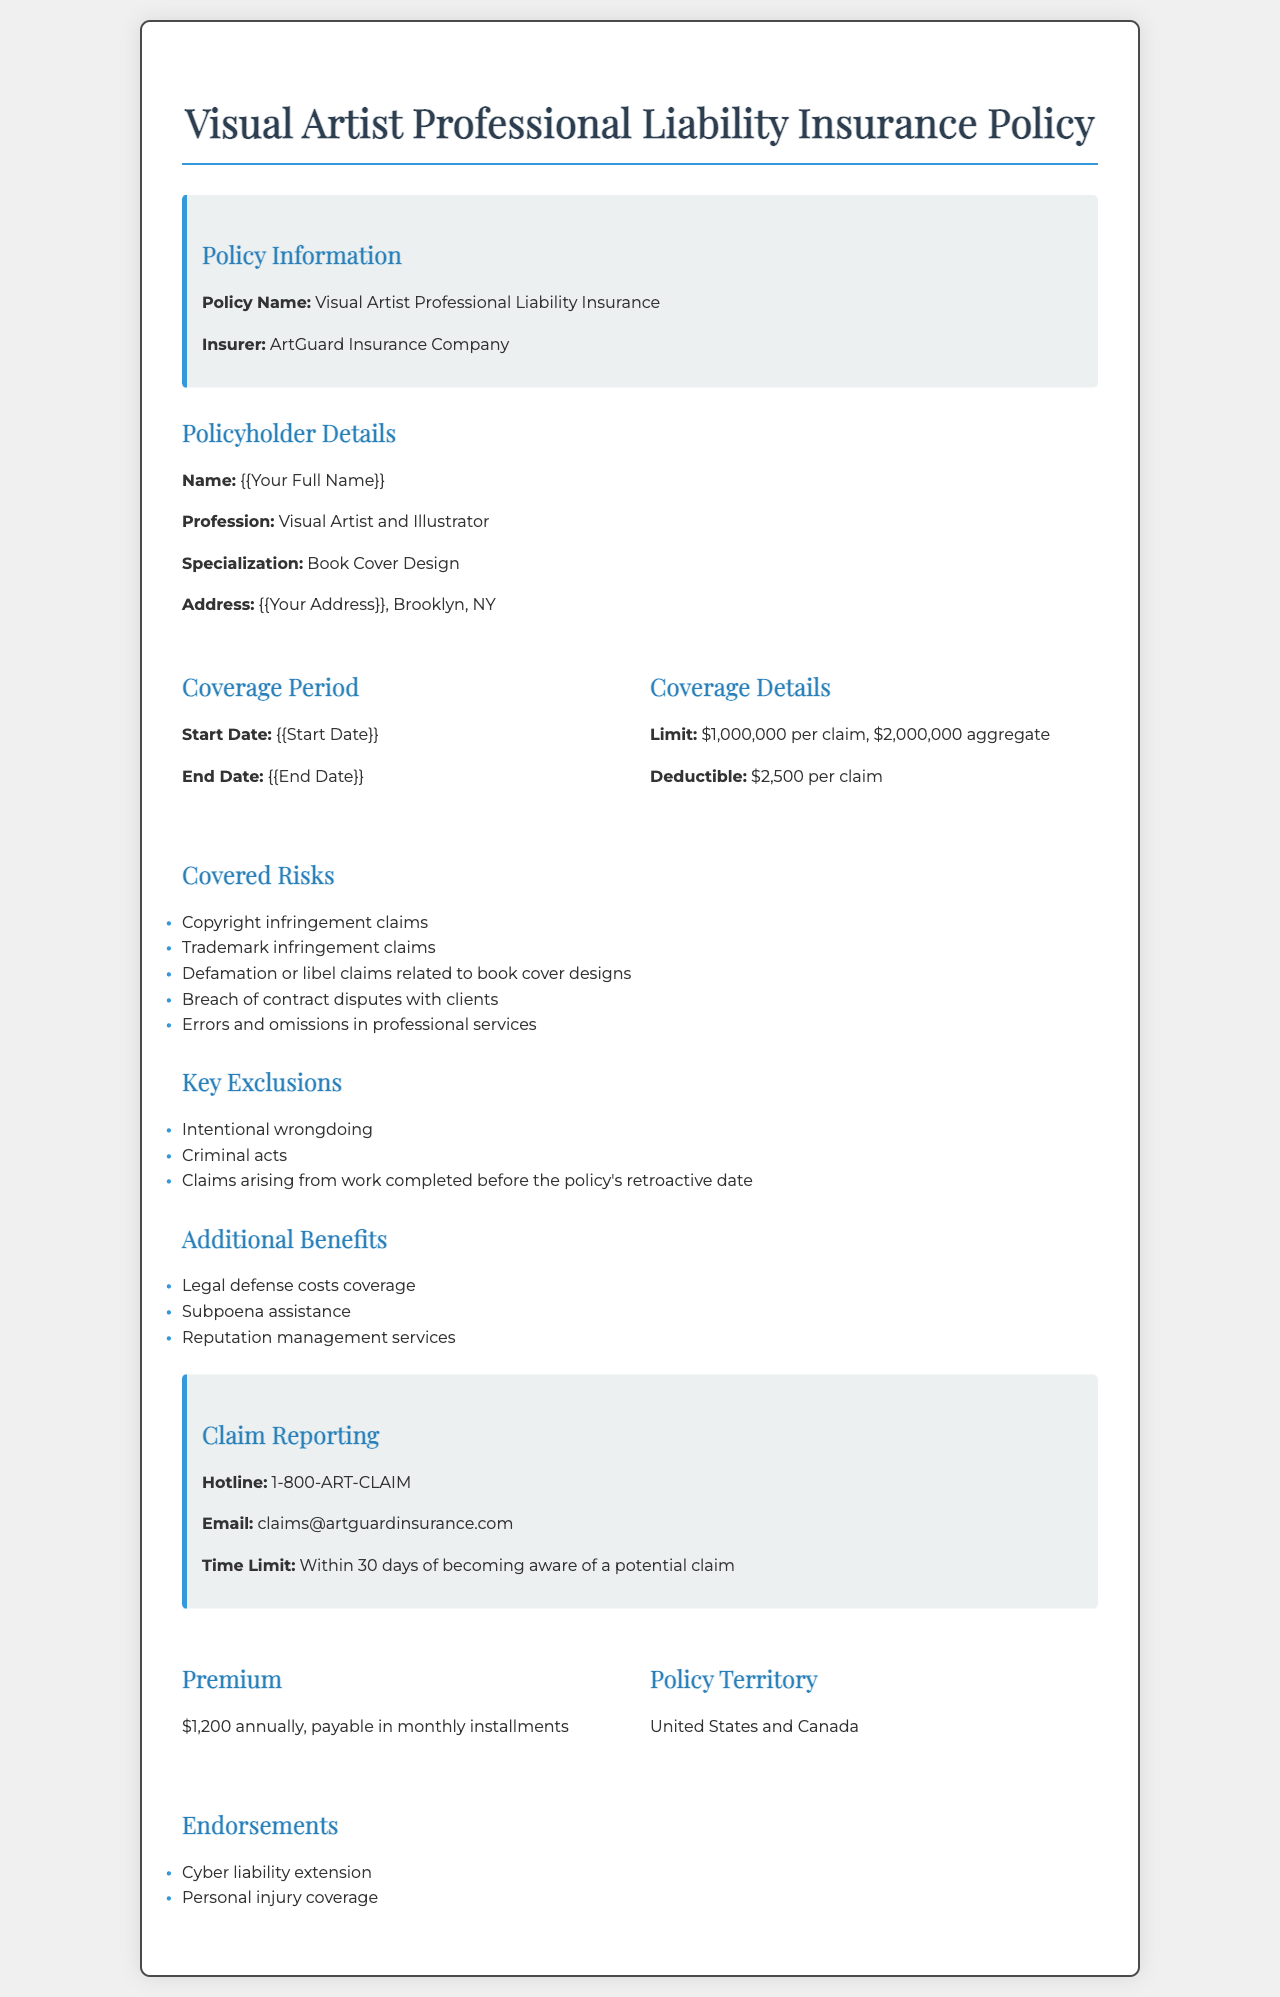what is the policy name? The policy name is stated in the document's title section.
Answer: Visual Artist Professional Liability Insurance who is the insurer? The insurer is mentioned in the policy information section.
Answer: ArtGuard Insurance Company what is the coverage limit per claim? The coverage limit details are provided under coverage details.
Answer: $1,000,000 per claim what is the deductible amount? The deductible amount is specified in the coverage details.
Answer: $2,500 per claim what is the hotline number for claim reporting? The hotline number for reporting claims is listed under the claim reporting section.
Answer: 1-800-ART-CLAIM name one of the key exclusions in the policy. This information can be found in the key exclusions section of the document.
Answer: Intentional wrongdoing what is the annual premium amount? The annual premium amount is stated in the premium section of the policy.
Answer: $1,200 annually what type of coverage is extended for cyber liability? This information is located in the endorsements section of the document.
Answer: Cyber liability extension what is the policy's coverage period start date? The coverage period start date is specified in the coverage period section.
Answer: {{Start Date}} 